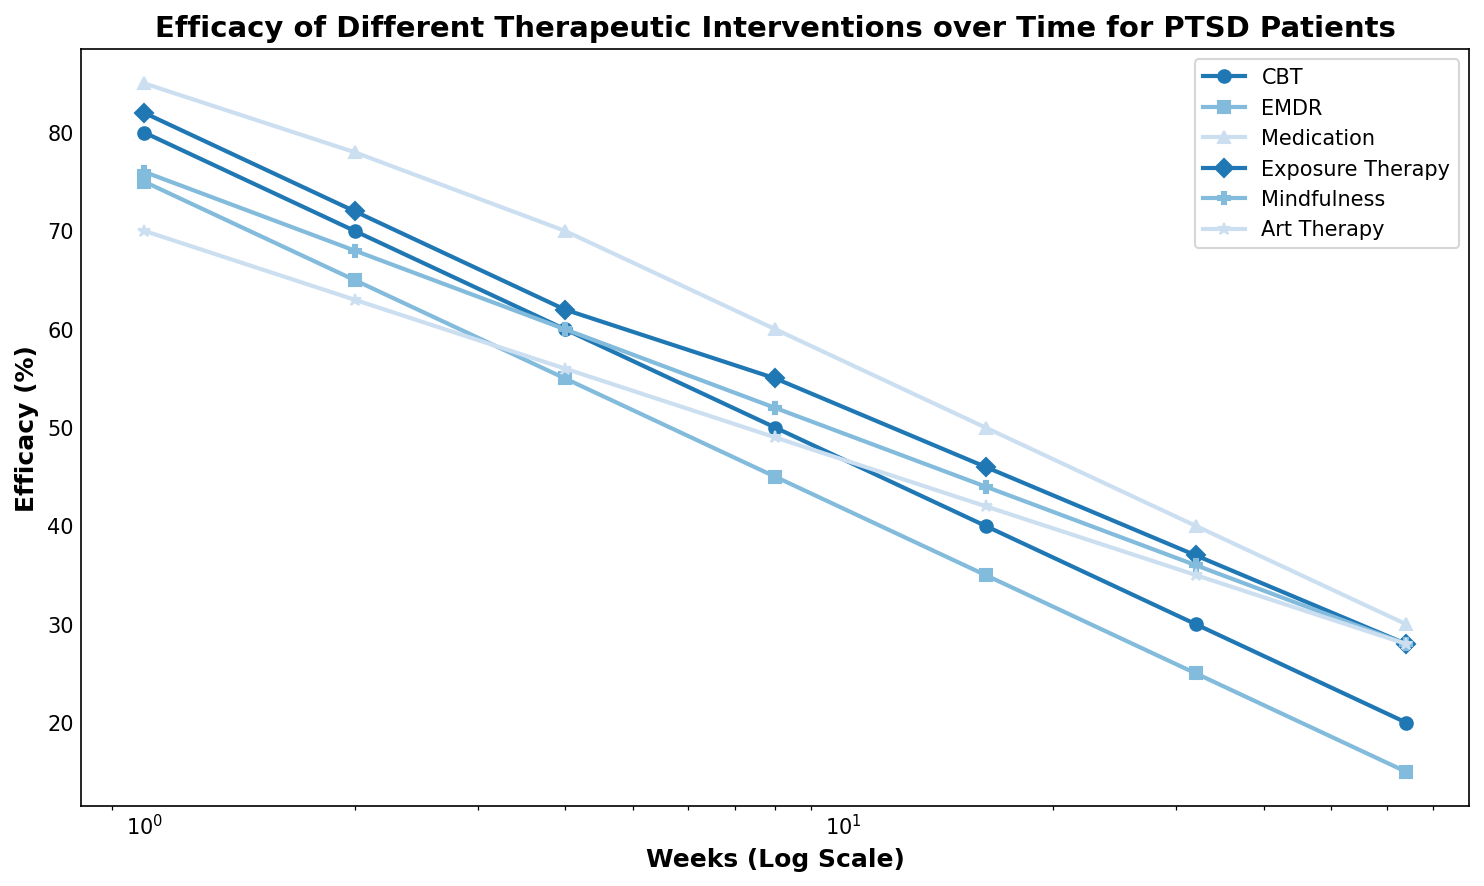what's the most effective intervention at Week 1? To identify the most effective intervention at Week 1, we need to look at the effectiveness percentages at that specific point. From the figure, Medication has the highest efficacy at Week 1 with 85%.
Answer: Medication what's the least effective intervention at Week 8? We need to compare the effectiveness percentages for all interventions at Week 8. The lowest value at Week 8 is Art Therapy at 49%.
Answer: Art Therapy which therapy shows the greatest decrease in efficacy from Week 1 to Week 64? To find this, we need to calculate the differences for each intervention between Week 1 and Week 64. The decrease for CBT is 60%, for EMDR is 60%, for Medication is 55%, for Exposure Therapy is 54%, for Mindfulness is 48%, for Art Therapy is 42%. Thus, CBT and EMDR both have the greatest decrease at 60%.
Answer: CBT and EMDR which intervention maintains the highest efficacy from Week 1 to Week 16? We need to track the highest efficacy values across Week 1 to Week 16 for each intervention. Medication consistently has the highest values at each of those weeks (85, 78, 70, 60, 50).
Answer: Medication what's the average efficacy of EMDR over the entire period? Calculate the average by summing the efficacy percentages at each week point for EMDR and then dividing by the number of weeks. (75 + 65 + 55 + 45 + 35 + 25 + 15) / 7 = 315 / 7 = 45.
Answer: 45 between Week 16 and Week 32, which intervention improves the most in efficacy? To find which intervention improves the most, we calculate the change in efficacy between Week 16 and Week 32 for each one. However, all interventions show a decrease rather than an improvement, hence no intervention improves.
Answer: None which intervention has the steepest decline between Week 4 and Week 8? Calculate the decline in efficacy for each intervention between Week 4 and Week 8. The steepest decline is for Medication (10).
Answer: Medication which therapy shows an efficacy percentage equal or greater than 60% up to Week 4? Identify interventions that have efficacy percentages >= 60% for Week 1, 2, and 4. CBT, EMDR, Medication, Exposure Therapy, and Mindfulness all meet this criterion.
Answer: CBT, EMDR, Medication, Exposure Therapy, and Mindfulness what's the difference in efficacy between CBT and Medication at Week 32? Subtract the efficacy value of CBT from that of Medication at Week 32. 40 - 30 = 10.
Answer: 10 